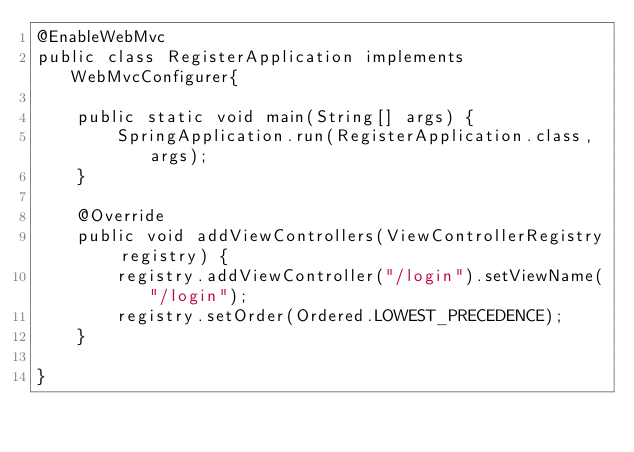<code> <loc_0><loc_0><loc_500><loc_500><_Java_>@EnableWebMvc
public class RegisterApplication implements WebMvcConfigurer{

	public static void main(String[] args) {
		SpringApplication.run(RegisterApplication.class, args);
	}
	
	@Override
	public void addViewControllers(ViewControllerRegistry registry) {
		registry.addViewController("/login").setViewName("/login");
		registry.setOrder(Ordered.LOWEST_PRECEDENCE);
	}

}
</code> 